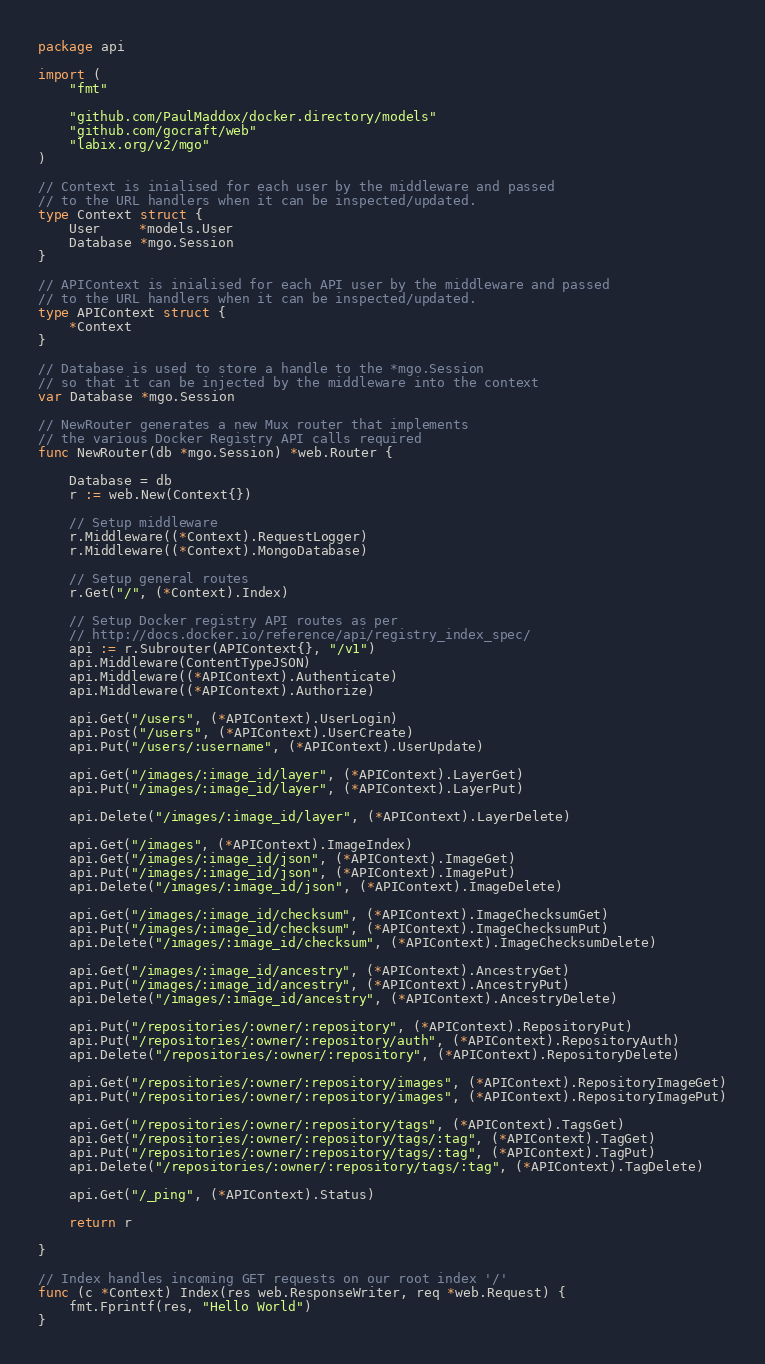Convert code to text. <code><loc_0><loc_0><loc_500><loc_500><_Go_>package api

import (
	"fmt"

	"github.com/PaulMaddox/docker.directory/models"
	"github.com/gocraft/web"
	"labix.org/v2/mgo"
)

// Context is inialised for each user by the middleware and passed
// to the URL handlers when it can be inspected/updated.
type Context struct {
	User     *models.User
	Database *mgo.Session
}

// APIContext is inialised for each API user by the middleware and passed
// to the URL handlers when it can be inspected/updated.
type APIContext struct {
	*Context
}

// Database is used to store a handle to the *mgo.Session
// so that it can be injected by the middleware into the context
var Database *mgo.Session

// NewRouter generates a new Mux router that implements
// the various Docker Registry API calls required
func NewRouter(db *mgo.Session) *web.Router {

	Database = db
	r := web.New(Context{})

	// Setup middleware
	r.Middleware((*Context).RequestLogger)
	r.Middleware((*Context).MongoDatabase)

	// Setup general routes
	r.Get("/", (*Context).Index)

	// Setup Docker registry API routes as per
	// http://docs.docker.io/reference/api/registry_index_spec/
	api := r.Subrouter(APIContext{}, "/v1")
	api.Middleware(ContentTypeJSON)
	api.Middleware((*APIContext).Authenticate)
	api.Middleware((*APIContext).Authorize)

	api.Get("/users", (*APIContext).UserLogin)
	api.Post("/users", (*APIContext).UserCreate)
	api.Put("/users/:username", (*APIContext).UserUpdate)

	api.Get("/images/:image_id/layer", (*APIContext).LayerGet)
	api.Put("/images/:image_id/layer", (*APIContext).LayerPut)

	api.Delete("/images/:image_id/layer", (*APIContext).LayerDelete)

	api.Get("/images", (*APIContext).ImageIndex)
	api.Get("/images/:image_id/json", (*APIContext).ImageGet)
	api.Put("/images/:image_id/json", (*APIContext).ImagePut)
	api.Delete("/images/:image_id/json", (*APIContext).ImageDelete)

	api.Get("/images/:image_id/checksum", (*APIContext).ImageChecksumGet)
	api.Put("/images/:image_id/checksum", (*APIContext).ImageChecksumPut)
	api.Delete("/images/:image_id/checksum", (*APIContext).ImageChecksumDelete)

	api.Get("/images/:image_id/ancestry", (*APIContext).AncestryGet)
	api.Put("/images/:image_id/ancestry", (*APIContext).AncestryPut)
	api.Delete("/images/:image_id/ancestry", (*APIContext).AncestryDelete)

	api.Put("/repositories/:owner/:repository", (*APIContext).RepositoryPut)
	api.Put("/repositories/:owner/:repository/auth", (*APIContext).RepositoryAuth)
	api.Delete("/repositories/:owner/:repository", (*APIContext).RepositoryDelete)

	api.Get("/repositories/:owner/:repository/images", (*APIContext).RepositoryImageGet)
	api.Put("/repositories/:owner/:repository/images", (*APIContext).RepositoryImagePut)

	api.Get("/repositories/:owner/:repository/tags", (*APIContext).TagsGet)
	api.Get("/repositories/:owner/:repository/tags/:tag", (*APIContext).TagGet)
	api.Put("/repositories/:owner/:repository/tags/:tag", (*APIContext).TagPut)
	api.Delete("/repositories/:owner/:repository/tags/:tag", (*APIContext).TagDelete)

	api.Get("/_ping", (*APIContext).Status)

	return r

}

// Index handles incoming GET requests on our root index '/'
func (c *Context) Index(res web.ResponseWriter, req *web.Request) {
	fmt.Fprintf(res, "Hello World")
}
</code> 